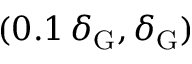Convert formula to latex. <formula><loc_0><loc_0><loc_500><loc_500>( 0 . 1 \, \delta _ { G } , \delta _ { G } )</formula> 